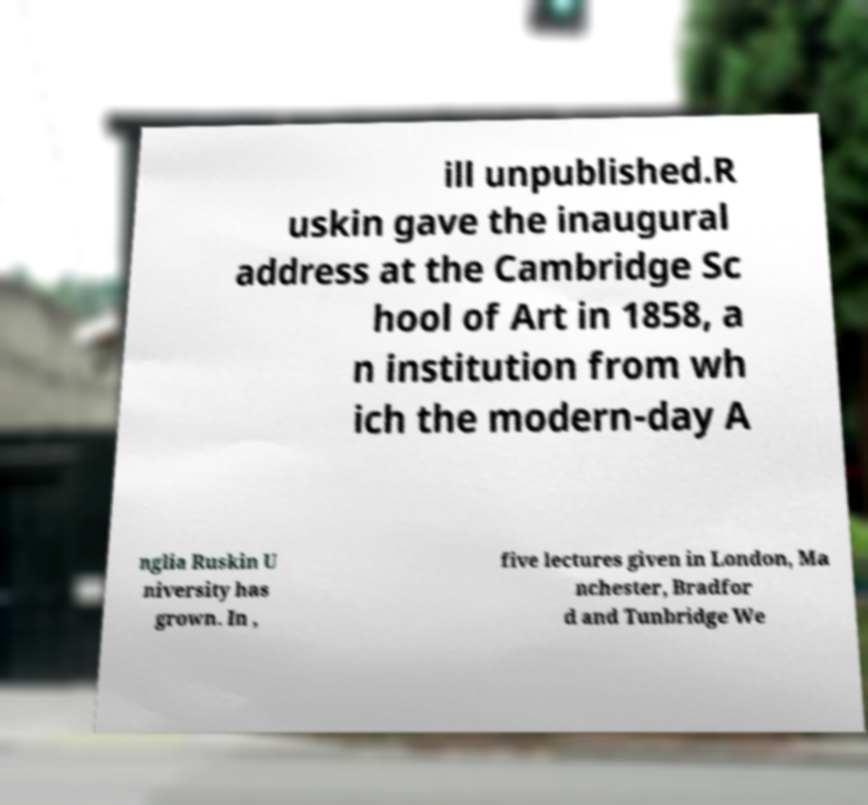What messages or text are displayed in this image? I need them in a readable, typed format. ill unpublished.R uskin gave the inaugural address at the Cambridge Sc hool of Art in 1858, a n institution from wh ich the modern-day A nglia Ruskin U niversity has grown. In , five lectures given in London, Ma nchester, Bradfor d and Tunbridge We 